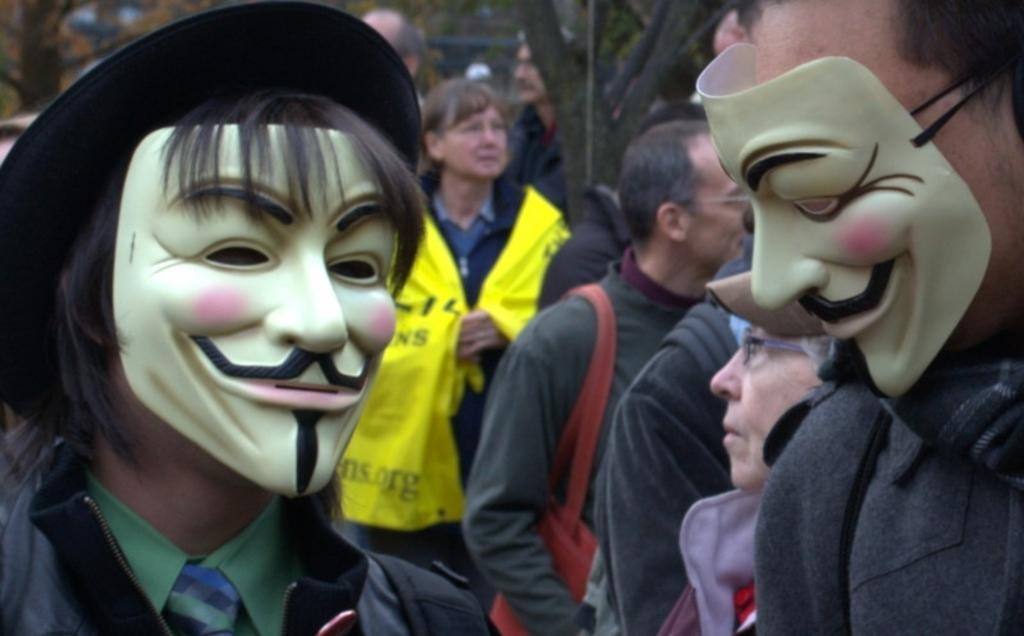How many people are wearing masks in the image? There are 2 people wearing masks in the image. What can be seen in the background of the image? There are many people standing on the street in the background of the image. What type of wool is being sold in the store in the image? There is no store or wool present in the image; it only shows people wearing masks and standing on the street. 